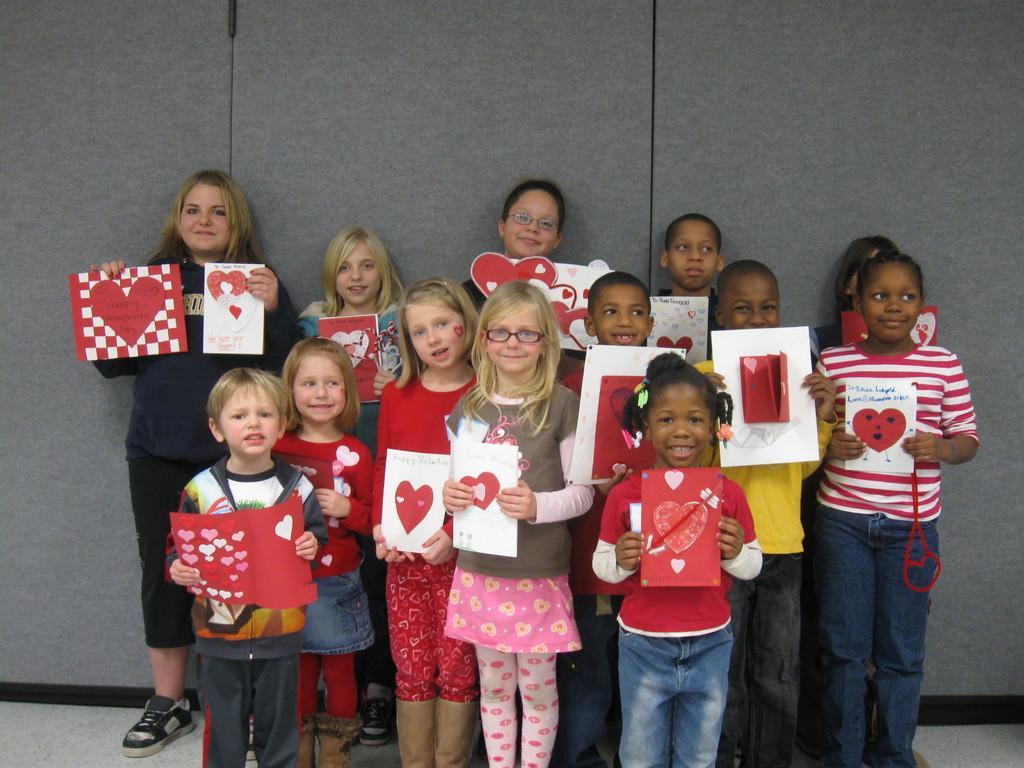Please provide a concise description of this image. Here I can see few children holding greeting cards in their hands, standing on the floor, smiling and giving pose for the picture. At the back of these children there is a wall. 